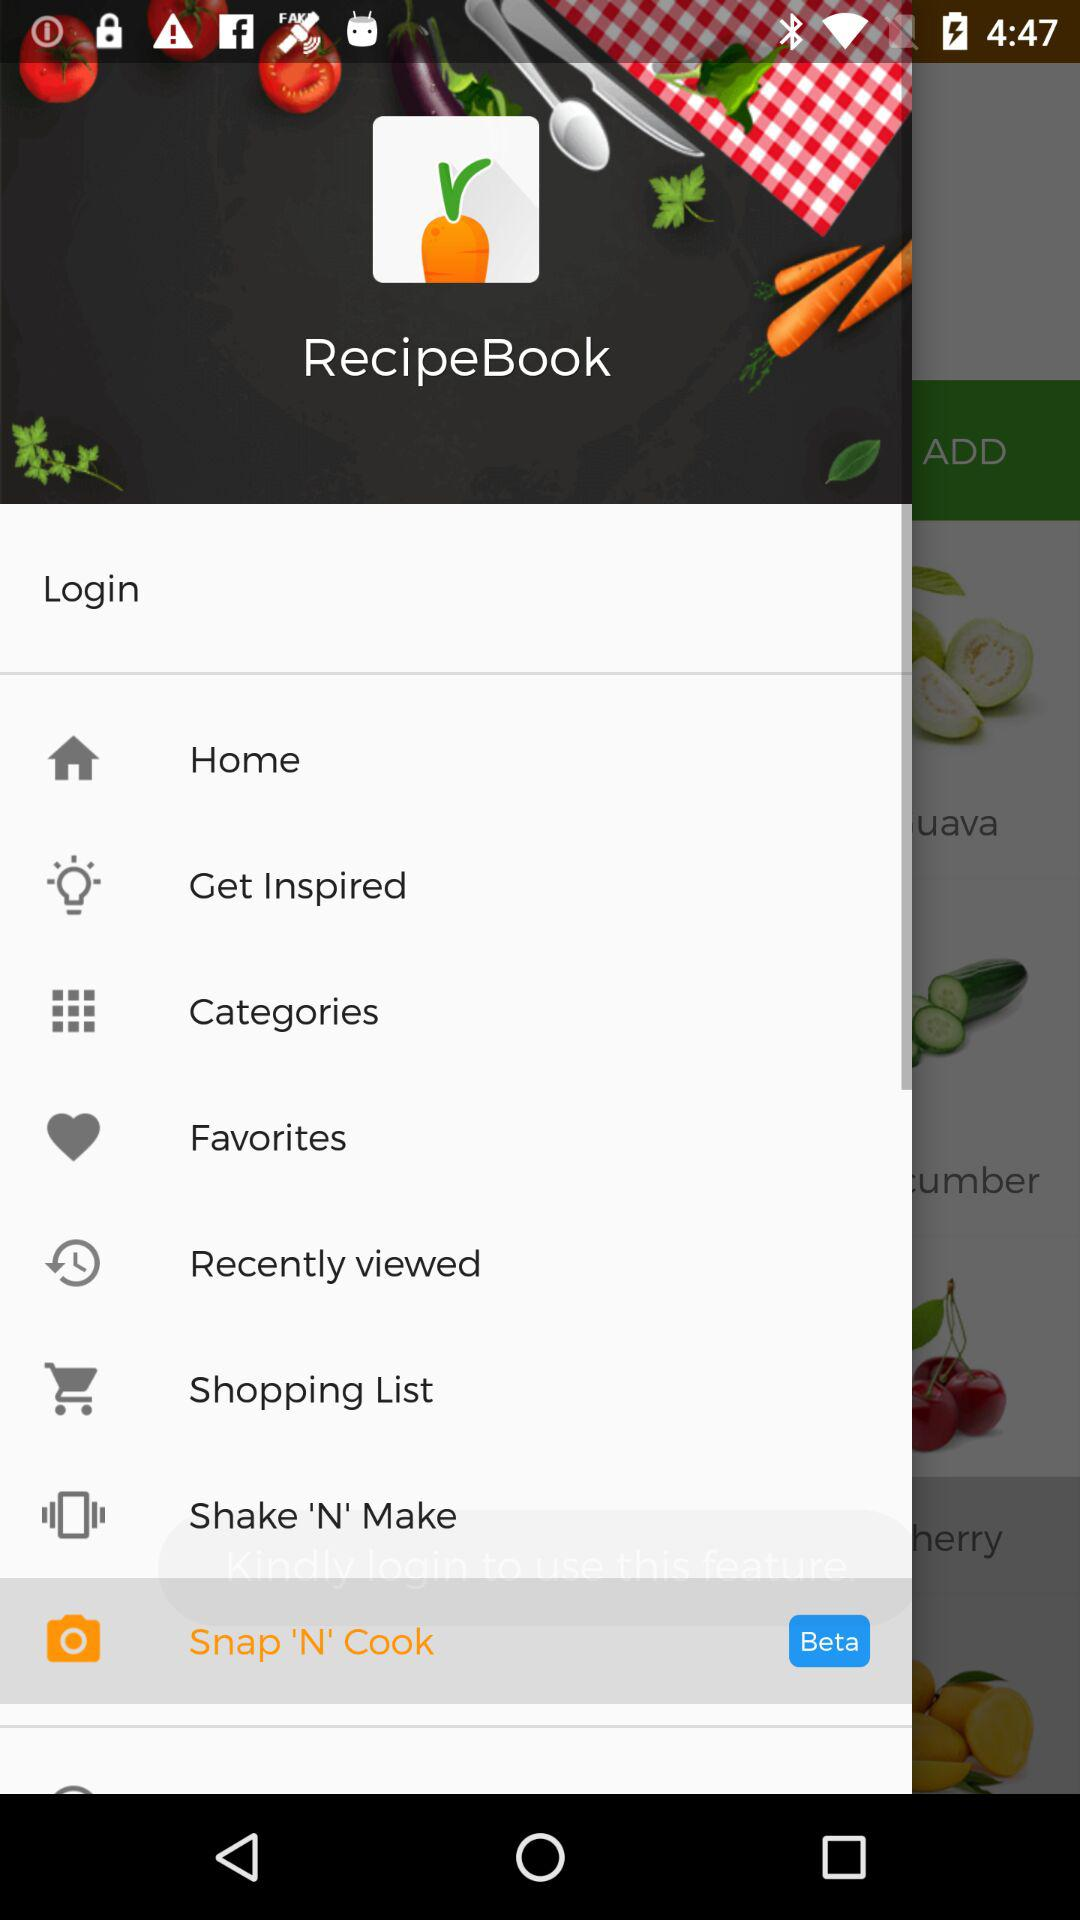Which option of "RecipeBook" has been selected? The selected option is "Snap 'N' Cook". 